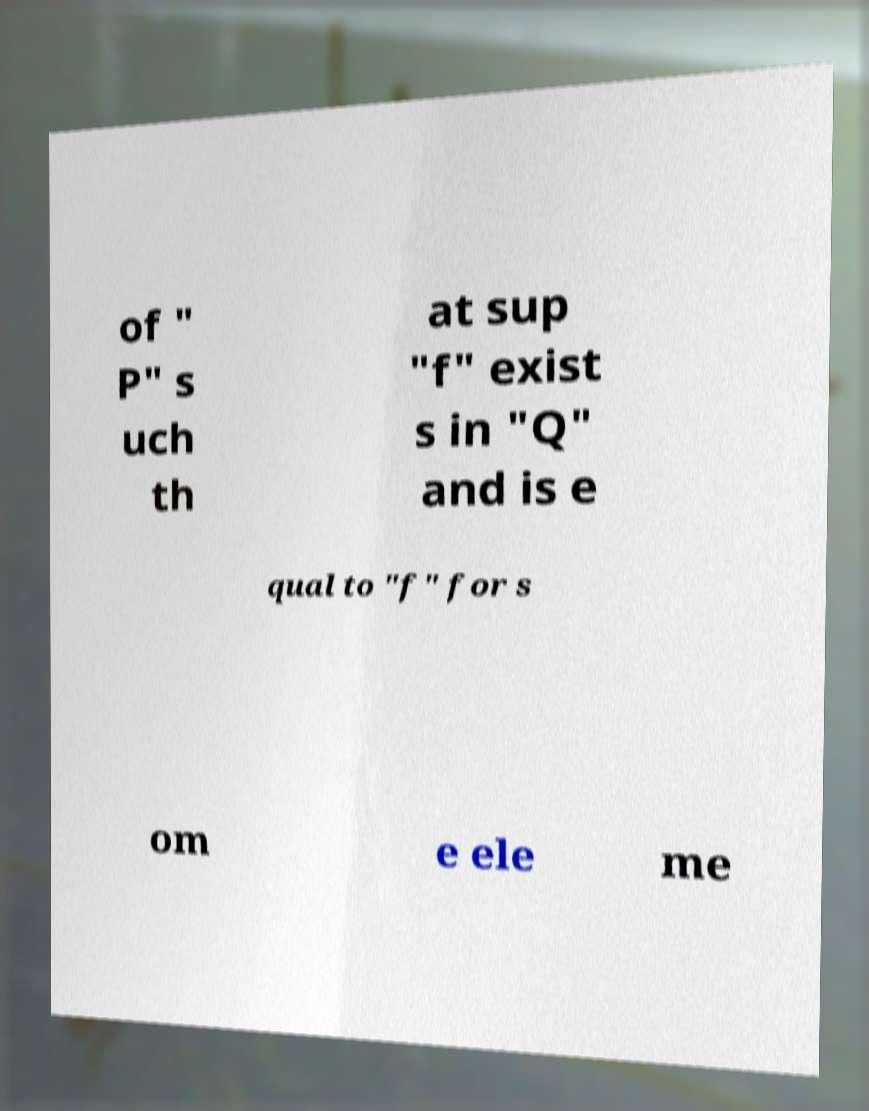What messages or text are displayed in this image? I need them in a readable, typed format. of " P" s uch th at sup "f" exist s in "Q" and is e qual to "f" for s om e ele me 